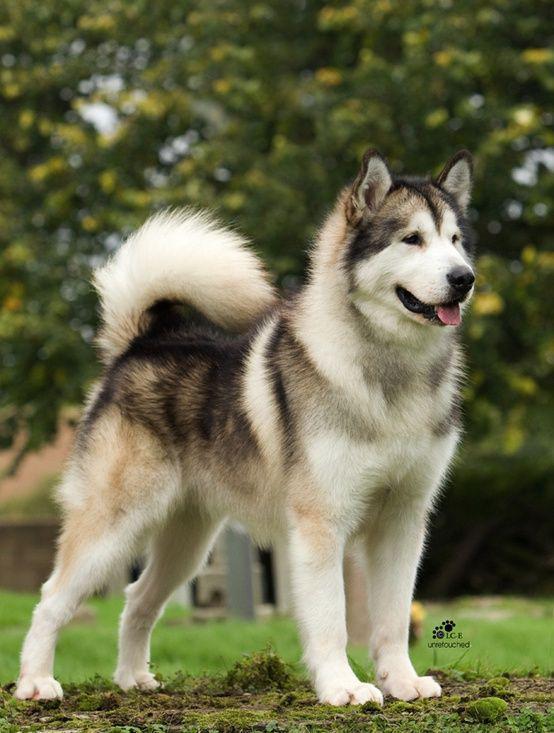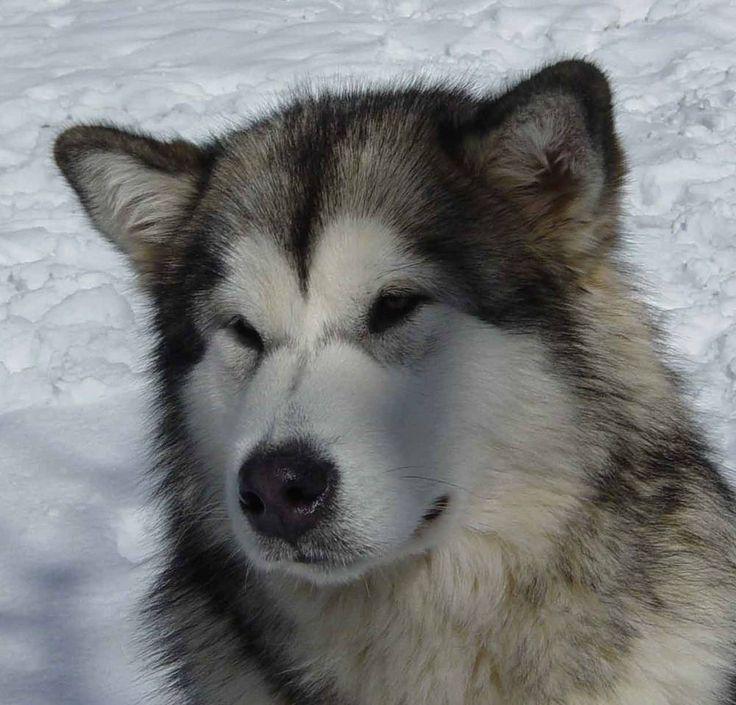The first image is the image on the left, the second image is the image on the right. Analyze the images presented: Is the assertion "The right image contains at least two dogs." valid? Answer yes or no. No. 